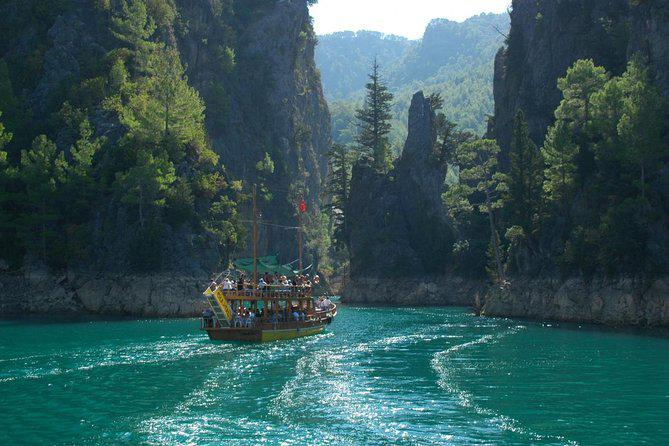How many boats are there in the image? 2 